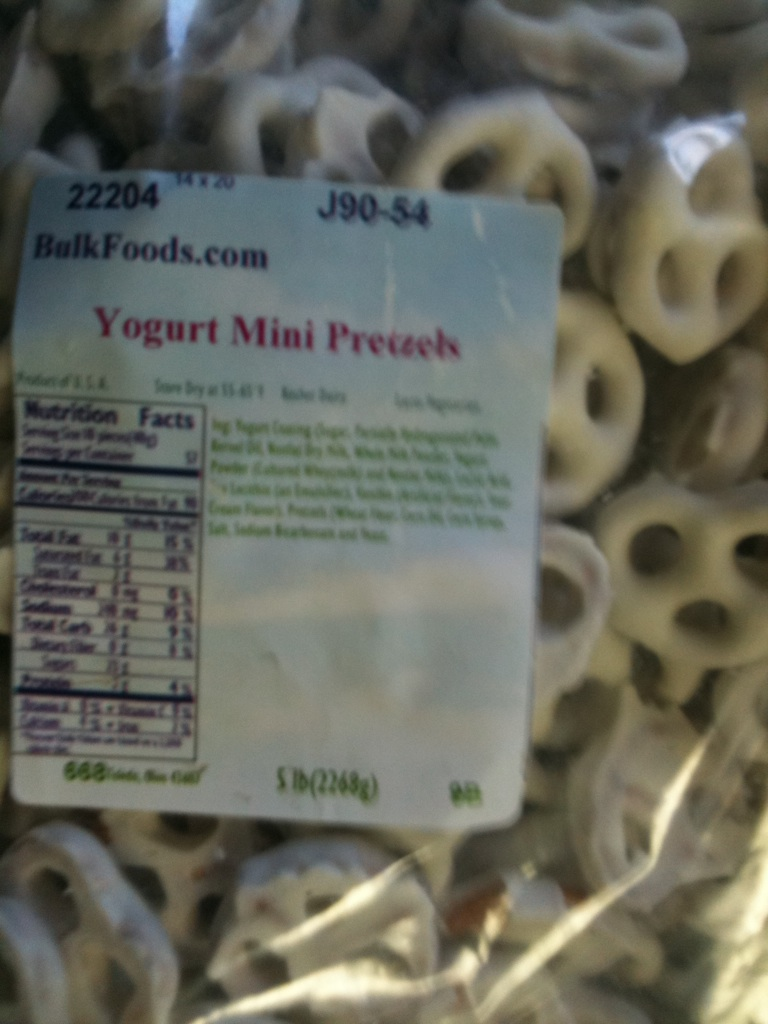If you were hosting a children's party, how could these pretzels be presented in a fun and engaging way? Children’s parties thrive on creativity and excitement. You could create a 'Snack Tasting Adventure,' where children go on a mini scavenger hunt, finding different snack stations around the party area. At the Yogurt Mini Pretzel station, you can have a 'Pretzel Decorating Corner' where kids use colored icing, edible glitter, and small candies to decorate their pretzels. This not only makes the pretzels a fun and interactive activity but also a tasty treat at the end! 
Can you create an elaborate story involving these pretzels? Once upon a time in the whimsical land of Snacketopia, a kingdom where every snack had a role, the Yogurt Mini Pretzels were the guardians of the Sweet-Salty Balance. One day, the balance started to tilt towards too salty after a mischievous clan of Potato Chips plotted to take over. The Yogurt Mini Pretzels, known for their harmonious blend of sweetness and saltiness, joined forces with the Caramel Popcorns to restore the balance. Their journey led them through the Crunchy Cookie Canyon and the Fizzy Soda Springs. After a dramatic encounter in the Sour Patch Forest, they managed to find the Hidden Sugar Crystals and used them to re-balance Snacketopia’s flavors, bringing peace and delicious harmony back to the land. 